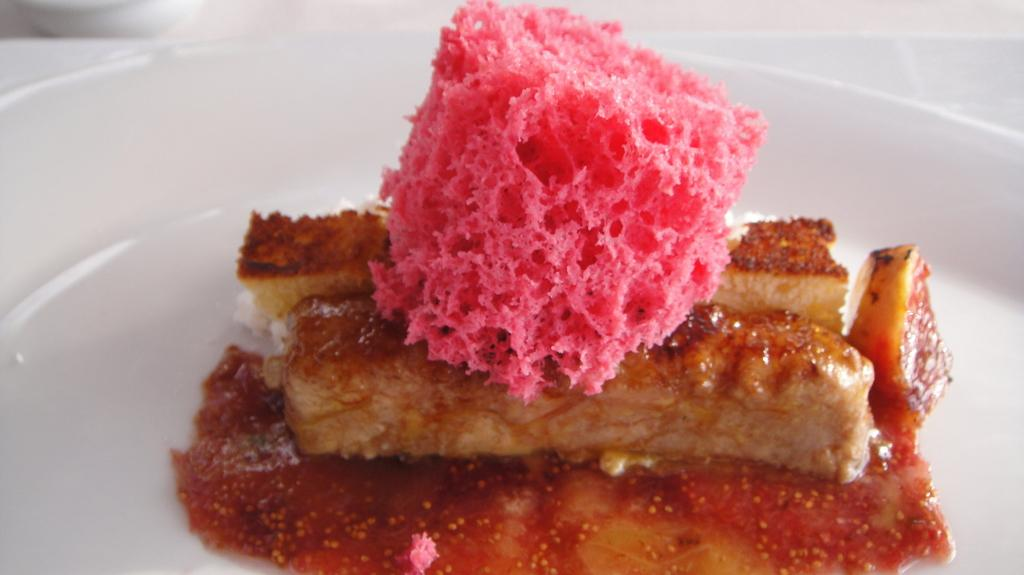What type of bread is in the image? There is a pink color bread in the image. How is the bread arranged in the image? The bread is on two cake pieces. What is the bread and cake pieces placed on? They are on a white color plate. What else can be seen in the image besides the bread and cake pieces? There is soup in the image. What is the color of the background in the image? The background of the image is white in color. What type of jeans is hanging on the wall in the image? There are no jeans present in the image; it features a pink color bread on cake pieces, soup, and a white background. What ornament is placed on the table in the image? There is no ornament present on the table in the image; it only features a plate with bread and cake pieces and a bowl of soup. 